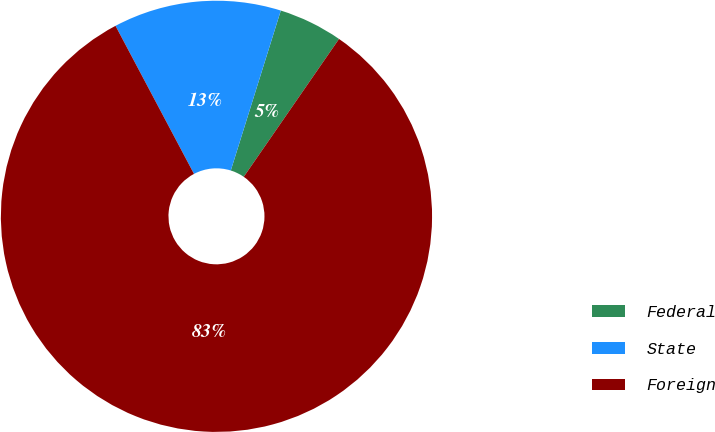Convert chart to OTSL. <chart><loc_0><loc_0><loc_500><loc_500><pie_chart><fcel>Federal<fcel>State<fcel>Foreign<nl><fcel>4.8%<fcel>12.58%<fcel>82.61%<nl></chart> 